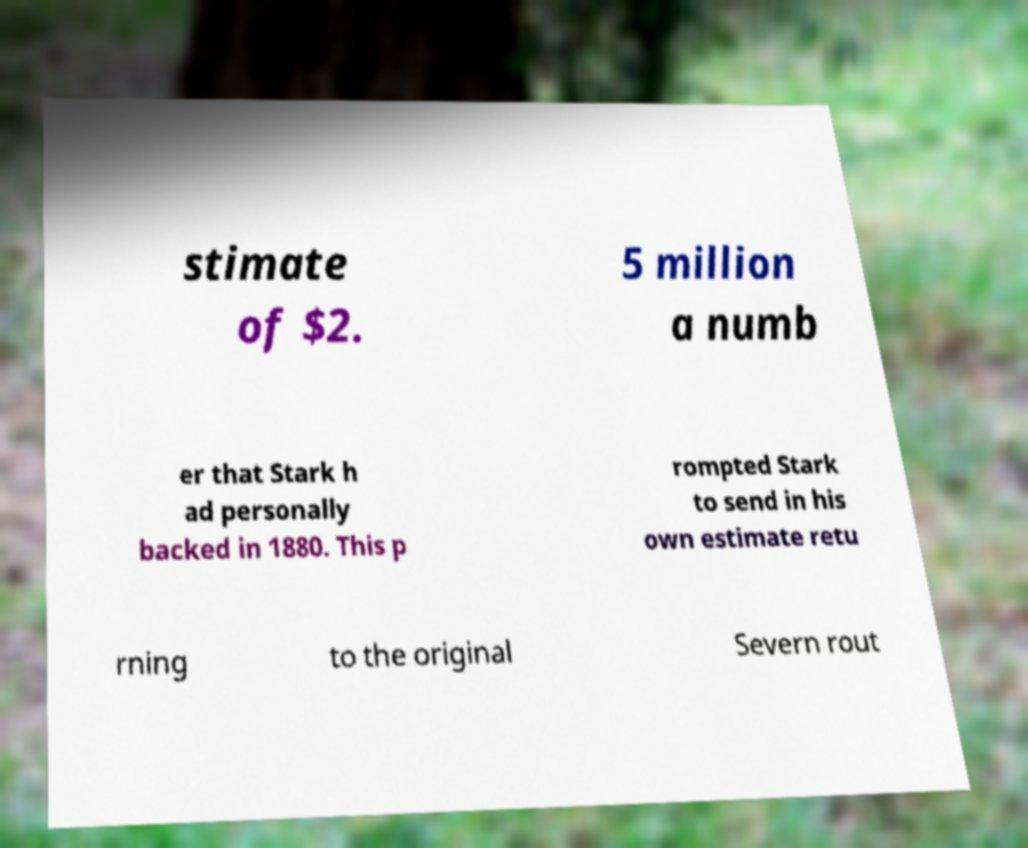I need the written content from this picture converted into text. Can you do that? stimate of $2. 5 million a numb er that Stark h ad personally backed in 1880. This p rompted Stark to send in his own estimate retu rning to the original Severn rout 